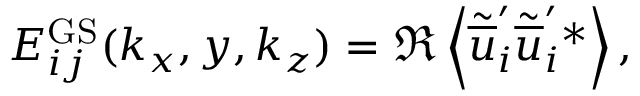Convert formula to latex. <formula><loc_0><loc_0><loc_500><loc_500>\begin{array} { r } { E _ { i j } ^ { G S } ( k _ { x } , y , k _ { z } ) = \Re \left < \tilde { \overline { u } } _ { i } ^ { \prime } \tilde { \overline { u } } _ { i } ^ { \prime ^ { * } \right > , } \end{array}</formula> 